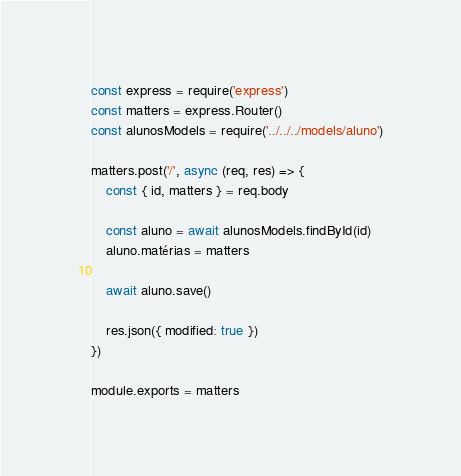Convert code to text. <code><loc_0><loc_0><loc_500><loc_500><_JavaScript_>const express = require('express')
const matters = express.Router()
const alunosModels = require('../../../models/aluno')

matters.post('/', async (req, res) => {
    const { id, matters } = req.body

    const aluno = await alunosModels.findById(id)
    aluno.matérias = matters

    await aluno.save()

    res.json({ modified: true })
})

module.exports = matters</code> 